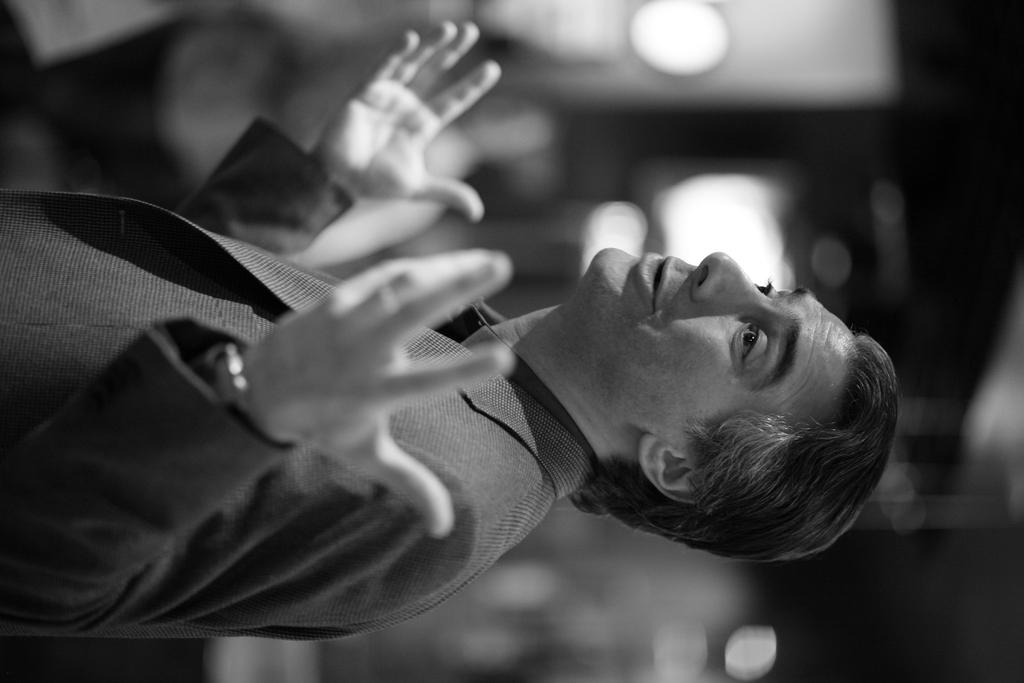What is the main subject of the image? There is a person standing in the middle of the image. Can you describe the background of the image? The background of the image is blurred. What type of thumb can be seen in the image? There is no thumb present in the image. Is the person in the image promoting peace? The image does not provide any information about the person promoting peace or any related symbols or gestures. 